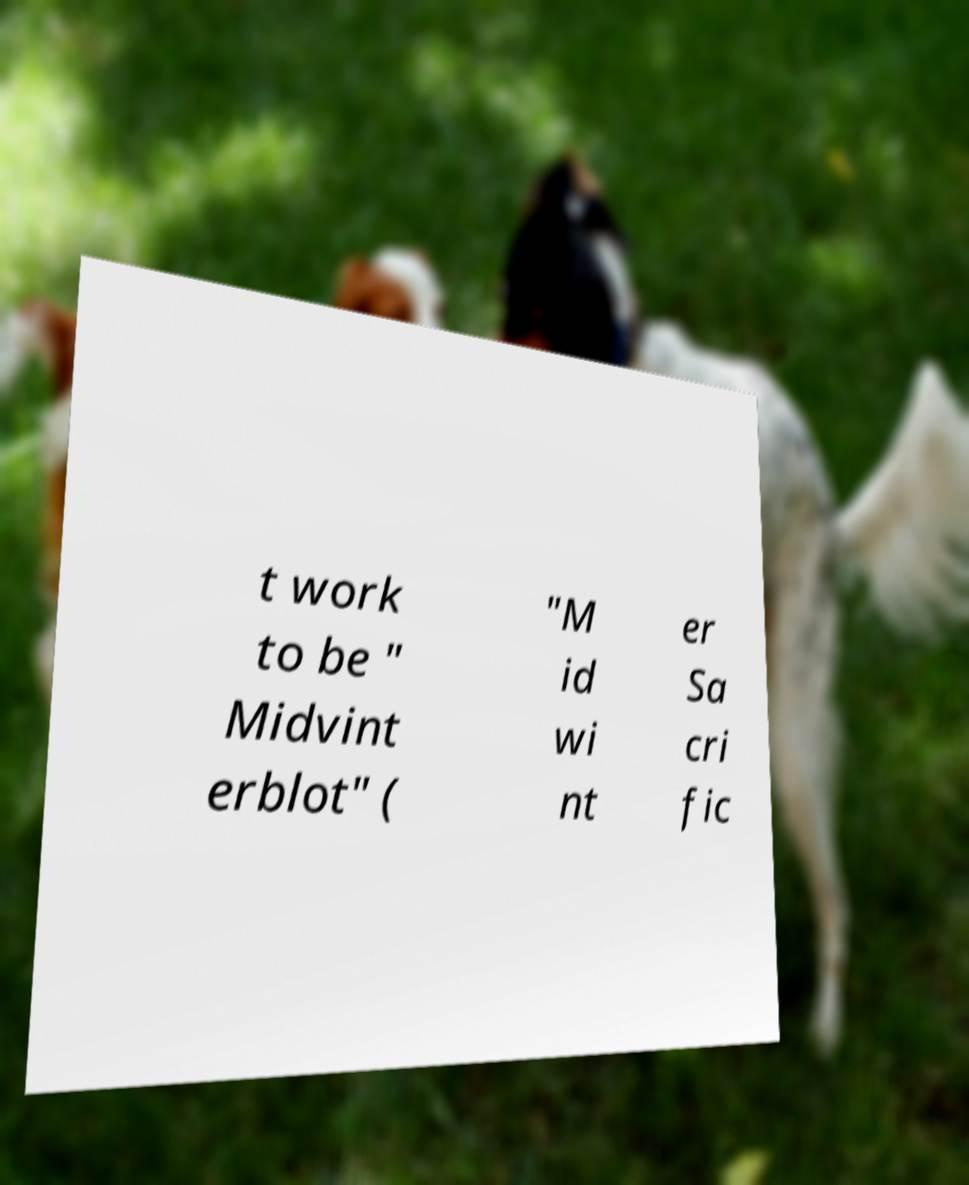What messages or text are displayed in this image? I need them in a readable, typed format. t work to be " Midvint erblot" ( "M id wi nt er Sa cri fic 